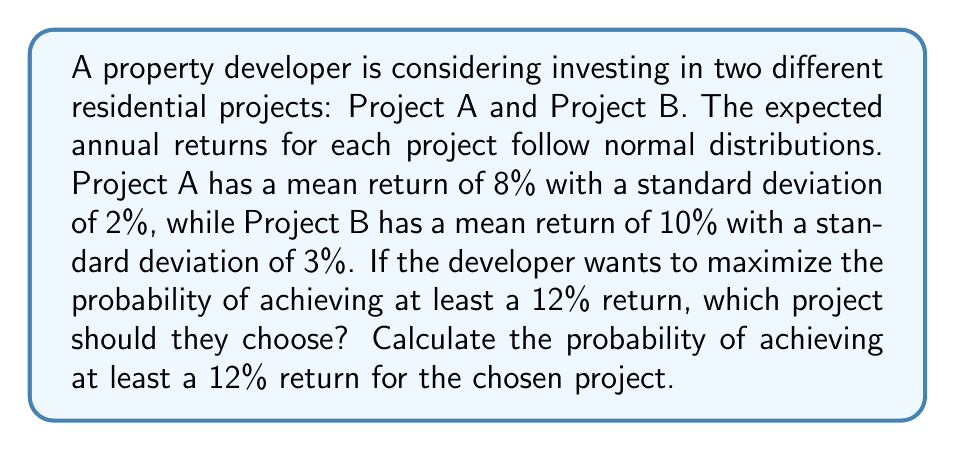Can you solve this math problem? To solve this problem, we need to calculate the probability of achieving at least a 12% return for both projects and compare them. We'll use the properties of the normal distribution and the z-score formula.

Step 1: Calculate the z-score for each project.
The z-score formula is: $z = \frac{x - \mu}{\sigma}$, where x is the target value, μ is the mean, and σ is the standard deviation.

For Project A:
$z_A = \frac{12\% - 8\%}{2\%} = \frac{4\%}{2\%} = 2$

For Project B:
$z_B = \frac{12\% - 10\%}{3\%} = \frac{2\%}{3\%} = \frac{2}{3} \approx 0.667$

Step 2: Find the probability of achieving at least a 12% return for each project.
We need to find P(X ≥ 12%) for both projects, which is equivalent to finding the area to the right of the z-score on a standard normal distribution.

For Project A:
P(X ≥ 12%) = 1 - P(Z ≤ 2) ≈ 1 - 0.9772 = 0.0228 or 2.28%

For Project B:
P(X ≥ 12%) = 1 - P(Z ≤ 0.667) ≈ 1 - 0.7477 = 0.2523 or 25.23%

Step 3: Compare the probabilities and choose the project with the higher probability.
Project B has a higher probability of achieving at least a 12% return (25.23% vs 2.28% for Project A).

Therefore, the developer should choose Project B to maximize the probability of achieving at least a 12% return.
Answer: Project B; 25.23% 